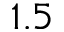Convert formula to latex. <formula><loc_0><loc_0><loc_500><loc_500>1 . 5</formula> 